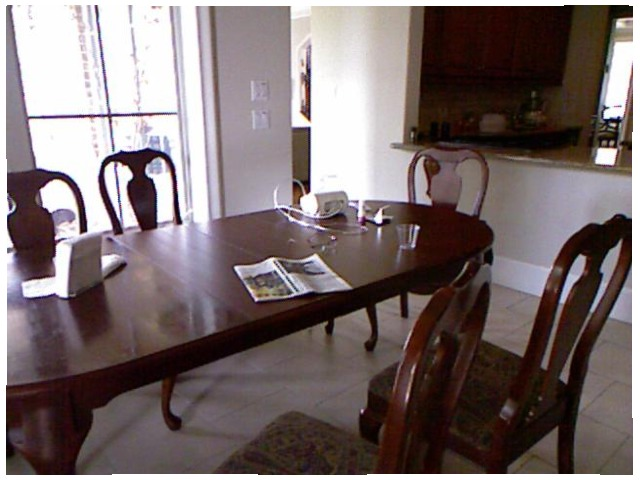<image>
Is there a table in front of the chair? Yes. The table is positioned in front of the chair, appearing closer to the camera viewpoint. Where is the cup in relation to the table? Is it on the table? Yes. Looking at the image, I can see the cup is positioned on top of the table, with the table providing support. Where is the newspaper in relation to the chair? Is it on the chair? No. The newspaper is not positioned on the chair. They may be near each other, but the newspaper is not supported by or resting on top of the chair. Is the newspaper on the floor? No. The newspaper is not positioned on the floor. They may be near each other, but the newspaper is not supported by or resting on top of the floor. 